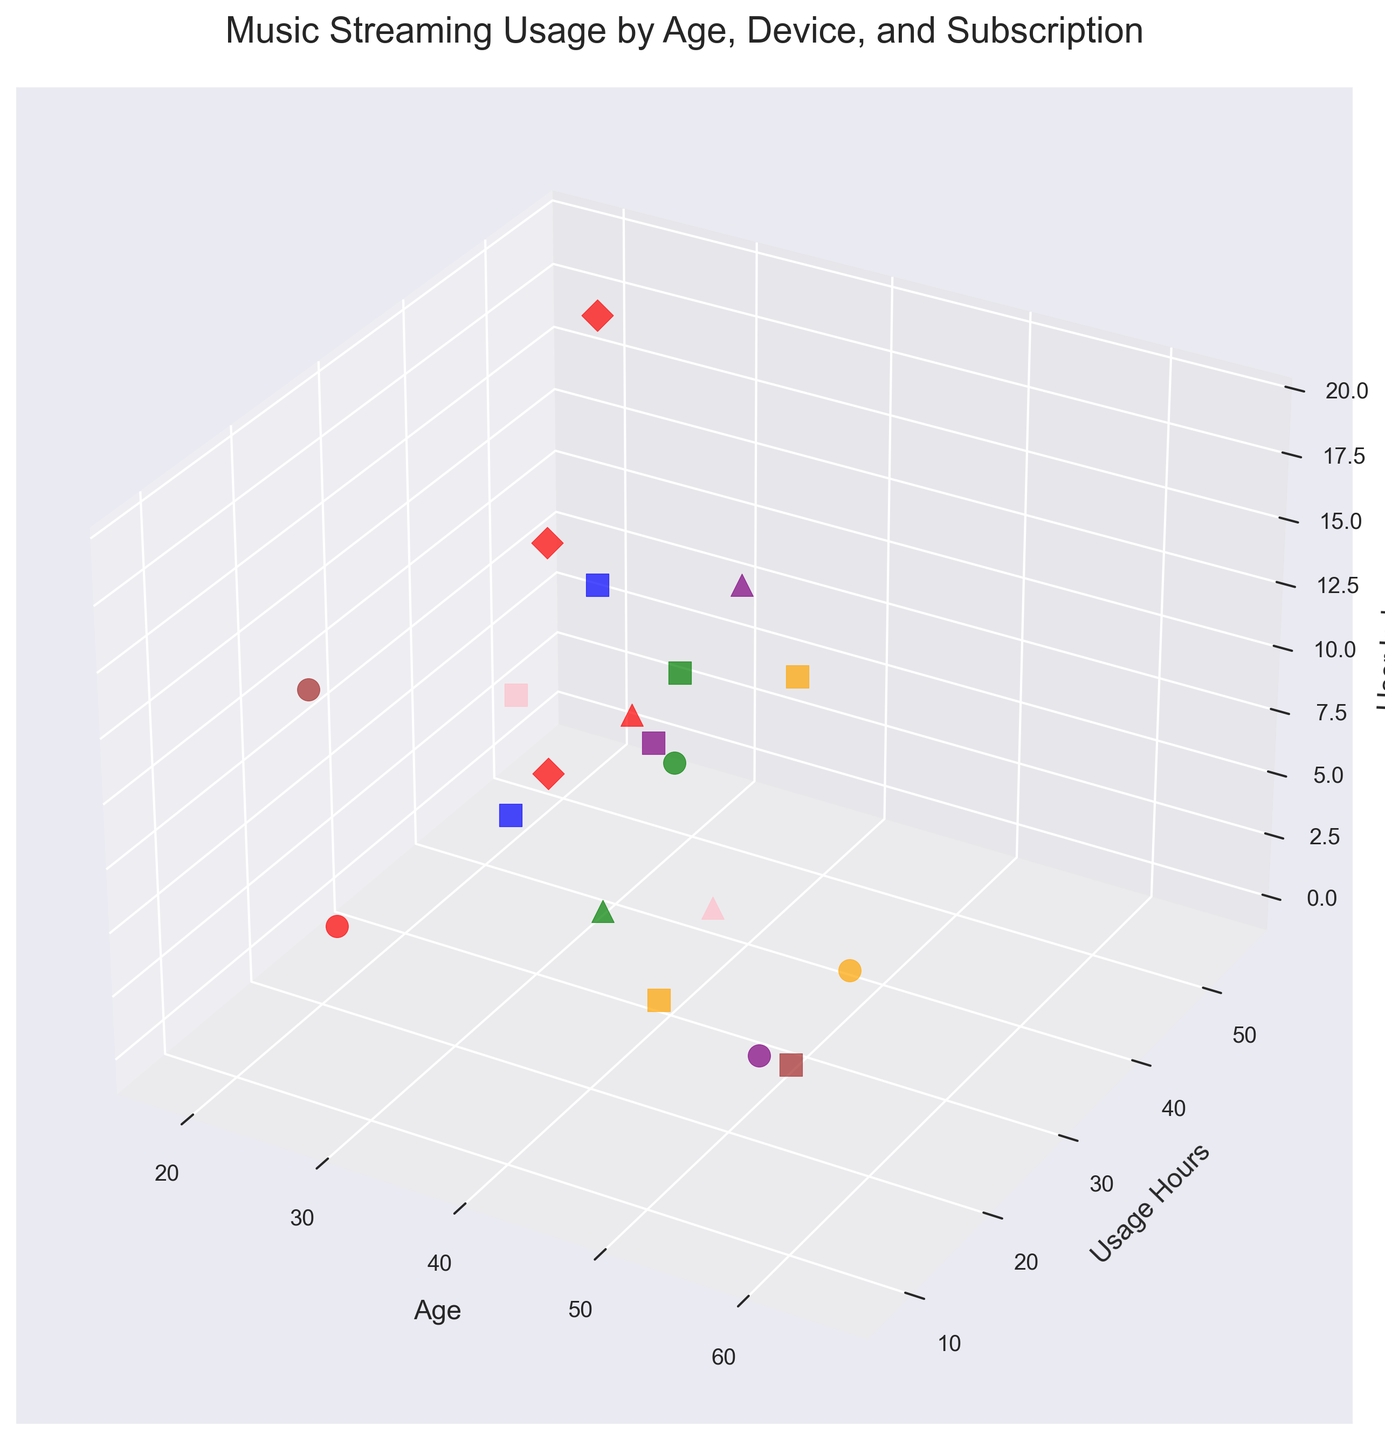How many different device types are represented in the plot? The plot legend shows a color-coded guide for the different devices. Counting the distinct colors indicates the number of device types.
Answer: 7 Which age group has the highest music usage hours? By observing the scatter plot, the data point with the highest 'Usage Hours' (Y-axis) is at age 20.
Answer: 20 What subscription type do most users in their 30s have? By focusing on the 3D scatter plot around the age group of 30s and observing different markers, the most frequent marker shape, associated with the 'Premium' subscription type, can be determined.
Answer: Premium Is there any user in their 50s who has a 'Student' subscription? Looking at the points with the 'D' marker type (for Student) and checking their position on the age axis (X-axis) will show if there are any in the 50s range (50-59).
Answer: No What is the usage pattern between 'Premium' and 'Free' subscription tiers? By comparing the scatter markers for 'Premium' (square) and 'Free' (circle), we can see that 'Premium' users (square markers) tend to have higher usage hours overall compared to 'Free' users (circle markers).
Answer: Premium users have higher usage How many users use a 'Smart Speaker' device? The legend and corresponding orange-colored points in the plot indicate 'Smart Speaker' users. Counting these points gives the number of users.
Answer: 3 What is the average usage hours for 'Premium' subscription users? Identify and sum the 'Premium' users' usage hours (points marked with squares) and then divide by the number of these users.
Answer: 27.286 Which device type has the highest average music usage hours? Calculate the average usage hours (Y-axis) for each device type, using the color legend to distinguish the devices. 'Smartphone' (red points) seems to dominate the highest usage figures overall.
Answer: Smartphone 